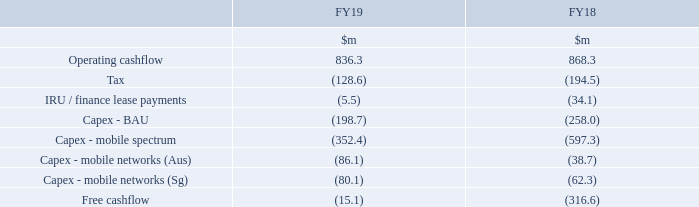Free cashflow
The Group achieved another year of strong cashflow performance with operating cashflow for FY19 of $836.3m again exceeding EBITDA. Tax payments in FY19 were significantly lower than the prior year because FY18 included tax paid on the capital gain realised on the sale of investments in FY17.
Capital expenditure
Business as usual (‘BAU’) capital expenditure of $198.7m was $59.3m lower than last year principally due to the substantial completion in the prior year of the build for the VHA fibre contract.
Mobile spectrum capex of $352.4m in FY19 reflects the payment during the year of the second instalment for the Australian 700MHz spectrum acquired at auction in April 2017. The first instalment of $597.3m was paid in FY18 and the third and final instalment of $352.4m is payable in January 2020. A further $86.1m of capex was also incurred in FY19 in relation to the Australian mobile network rollout up until the project ceased. This expenditure on spectrum and mobile assets in Australia was partly impaired as part of the impairment review that was undertaken following the cessation of the project as described above.
Capex for the mobile network build in Singapore in FY19 was $80.1m taking the aggregate capex incurred on the project up to $147m (excluding spectrum).
Why was there a change in the BAU capital expenditure from FY18 to FY19? Due to the substantial completion in the prior year of the build for the vha fibre contract. Which capital expenditures had increased from FY18 to FY19? Capex - mobile networks (aus), capex - mobile networks (sg). Why was there a change in tax payments from FY18 to FY19? Because fy18 included tax paid on the capital gain realised on the sale of investments in fy17. What is the total cost of the Australian 700MHz spectrum?
Answer scale should be: million. 352.4 + 597.3 + 352.4
Answer: 1302.1. What is the percentage change of free cashflow from FY18 to FY19?
Answer scale should be: percent. (15.1 - 316.6) / 316.6
Answer: -95.23. How much capital expenditure was incurred on the Singapore project prior to FY19?
Answer scale should be: million. 147 - 80.1
Answer: 66.9. 